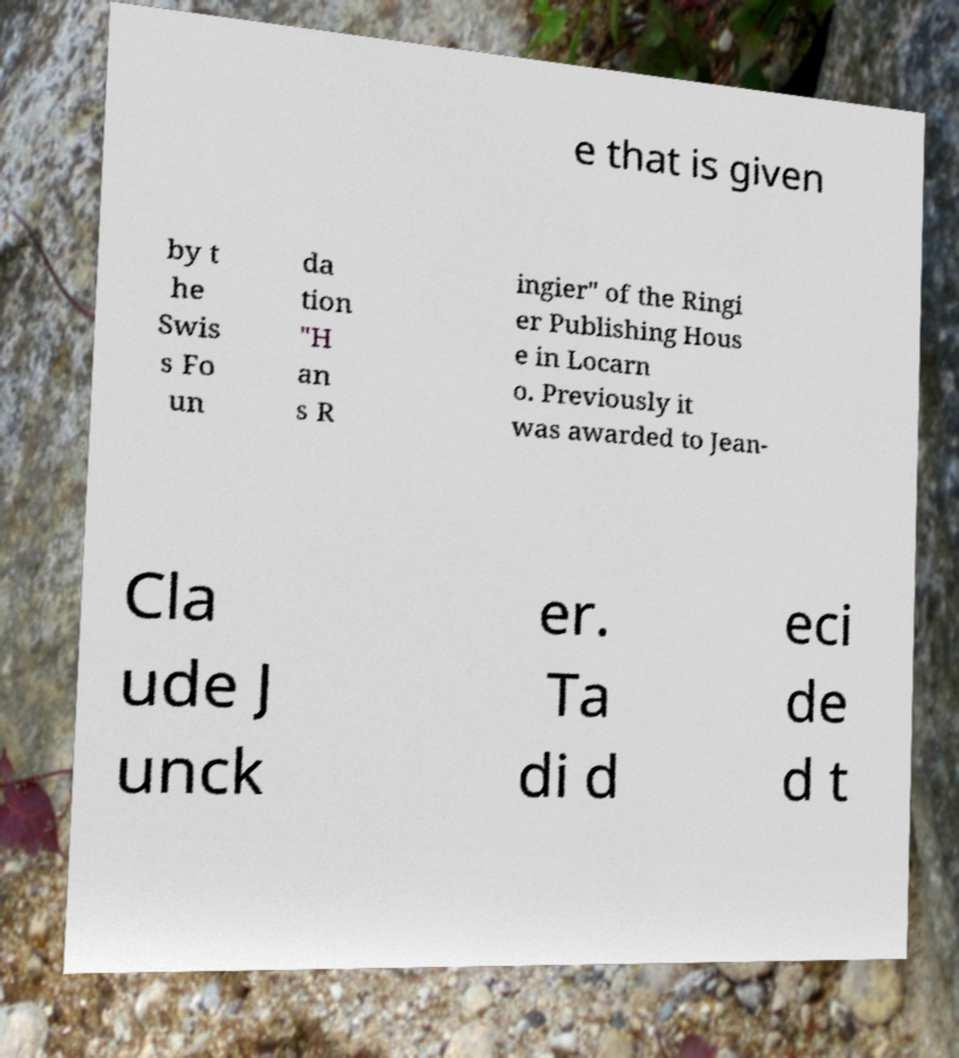Could you assist in decoding the text presented in this image and type it out clearly? e that is given by t he Swis s Fo un da tion "H an s R ingier" of the Ringi er Publishing Hous e in Locarn o. Previously it was awarded to Jean- Cla ude J unck er. Ta di d eci de d t 